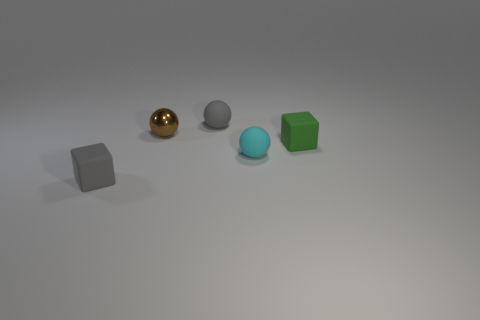There is a sphere that is left of the small rubber object behind the shiny ball; what is its material?
Ensure brevity in your answer.  Metal. Is the number of matte cubes right of the gray block greater than the number of red metallic blocks?
Offer a very short reply. Yes. Are any purple cylinders visible?
Keep it short and to the point. No. The tiny thing that is in front of the cyan object is what color?
Your answer should be very brief. Gray. There is a brown ball that is the same size as the cyan thing; what material is it?
Your response must be concise. Metal. What number of other objects are the same material as the small cyan thing?
Offer a very short reply. 3. What color is the sphere that is behind the tiny cyan object and to the right of the metallic ball?
Provide a short and direct response. Gray. How many things are either blocks that are to the right of the cyan object or small cyan things?
Offer a very short reply. 2. How many other objects are the same color as the metallic thing?
Offer a very short reply. 0. Are there the same number of tiny rubber objects that are in front of the gray sphere and small spheres?
Offer a terse response. Yes. 